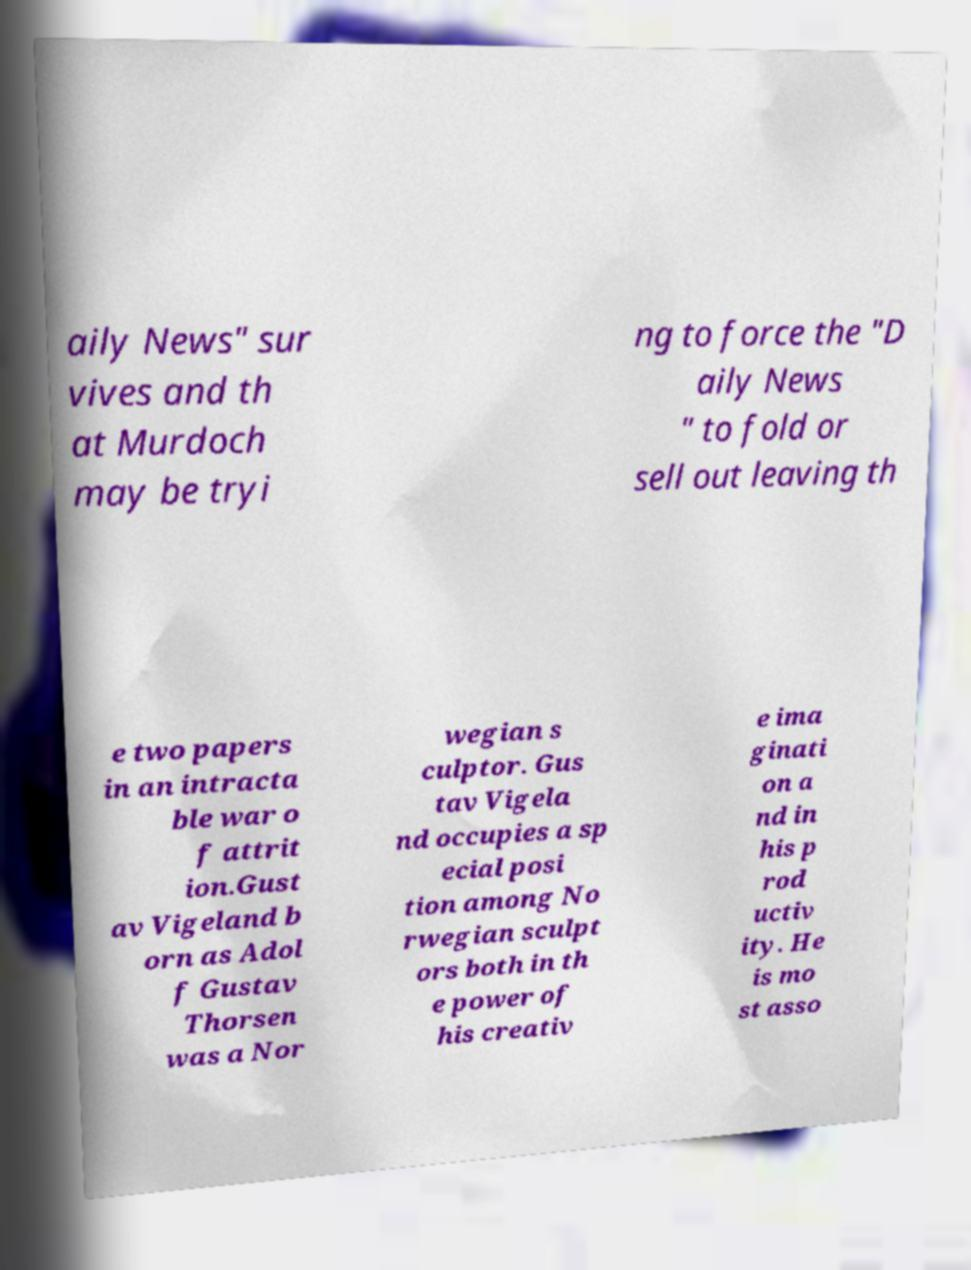For documentation purposes, I need the text within this image transcribed. Could you provide that? aily News" sur vives and th at Murdoch may be tryi ng to force the "D aily News " to fold or sell out leaving th e two papers in an intracta ble war o f attrit ion.Gust av Vigeland b orn as Adol f Gustav Thorsen was a Nor wegian s culptor. Gus tav Vigela nd occupies a sp ecial posi tion among No rwegian sculpt ors both in th e power of his creativ e ima ginati on a nd in his p rod uctiv ity. He is mo st asso 